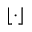<formula> <loc_0><loc_0><loc_500><loc_500>\lfloor \cdot \rfloor</formula> 